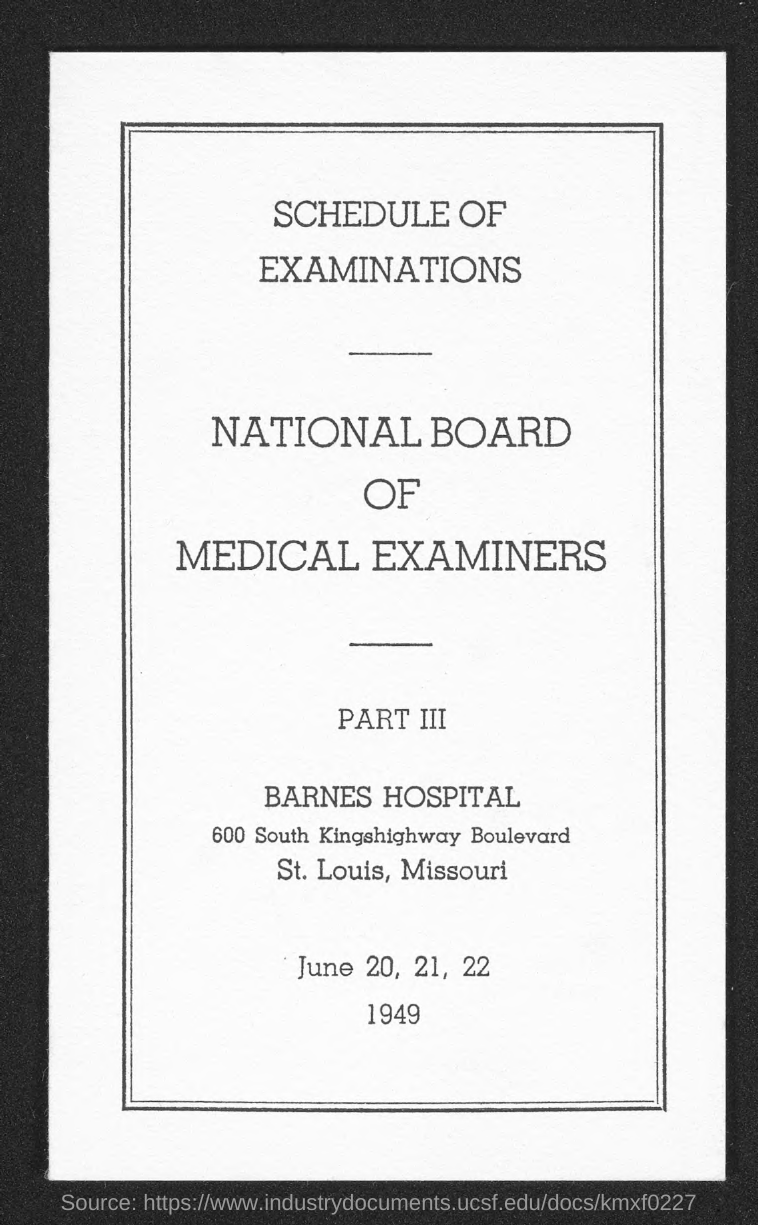Point out several critical features in this image. The title of the document is 'Schedule of Examinations'. 